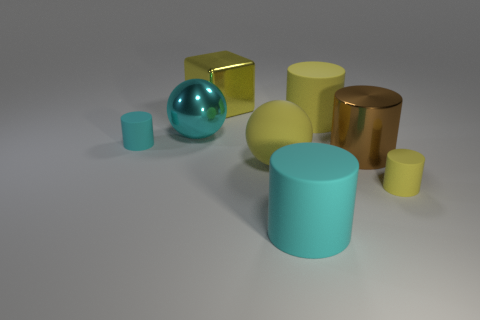Subtract all small yellow matte cylinders. How many cylinders are left? 4 Subtract all red cylinders. Subtract all blue balls. How many cylinders are left? 5 Add 2 tiny green matte objects. How many objects exist? 10 Subtract all cylinders. How many objects are left? 3 Add 3 cyan things. How many cyan things are left? 6 Add 4 big brown cylinders. How many big brown cylinders exist? 5 Subtract 0 red cylinders. How many objects are left? 8 Subtract all big matte things. Subtract all big yellow balls. How many objects are left? 4 